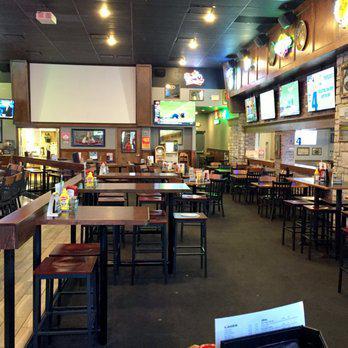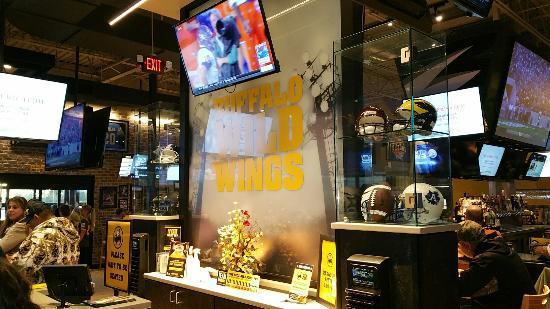The first image is the image on the left, the second image is the image on the right. Evaluate the accuracy of this statement regarding the images: "An image shows at least one customer in a bar equipped with a suspended TV screen.". Is it true? Answer yes or no. Yes. The first image is the image on the left, the second image is the image on the right. Analyze the images presented: Is the assertion "In one image, the restaurant with overhead television screens has seating on tall stools at tables with wooden tops." valid? Answer yes or no. Yes. 